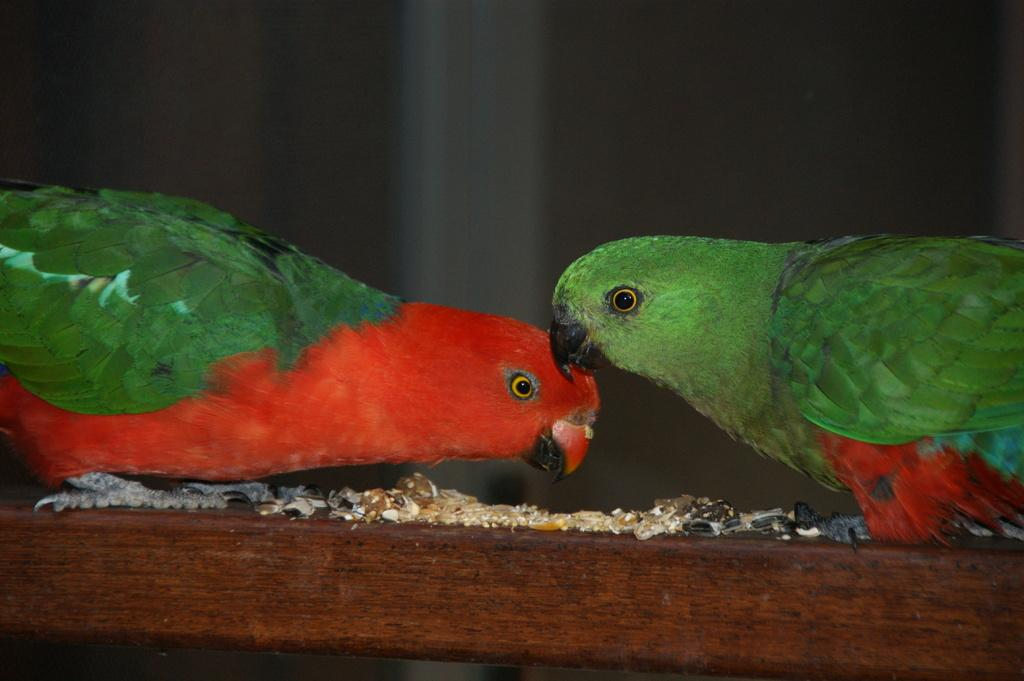How many parrots are in the image? There are two parrots in the image. Where are the parrots located? The parrots are on a wooden block. How many visitors can be seen in the image? There are no visitors present in the image; it only features two parrots on a wooden block. What type of trail is visible in the image? There is no trail present in the image; it only features two parrots on a wooden block. 